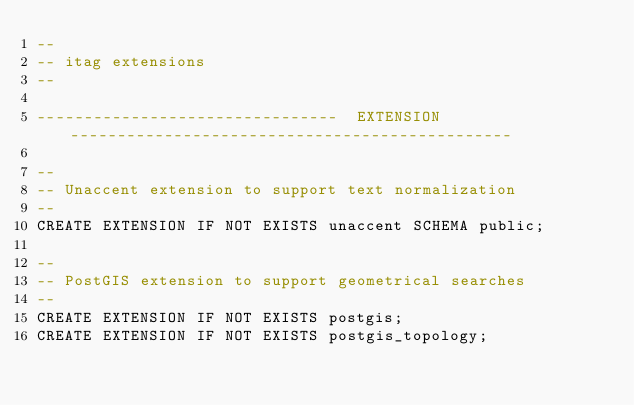<code> <loc_0><loc_0><loc_500><loc_500><_SQL_>--
-- itag extensions
--

--------------------------------  EXTENSION -----------------------------------------------

--
-- Unaccent extension to support text normalization
--
CREATE EXTENSION IF NOT EXISTS unaccent SCHEMA public;

-- 
-- PostGIS extension to support geometrical searches
--
CREATE EXTENSION IF NOT EXISTS postgis;
CREATE EXTENSION IF NOT EXISTS postgis_topology;
</code> 